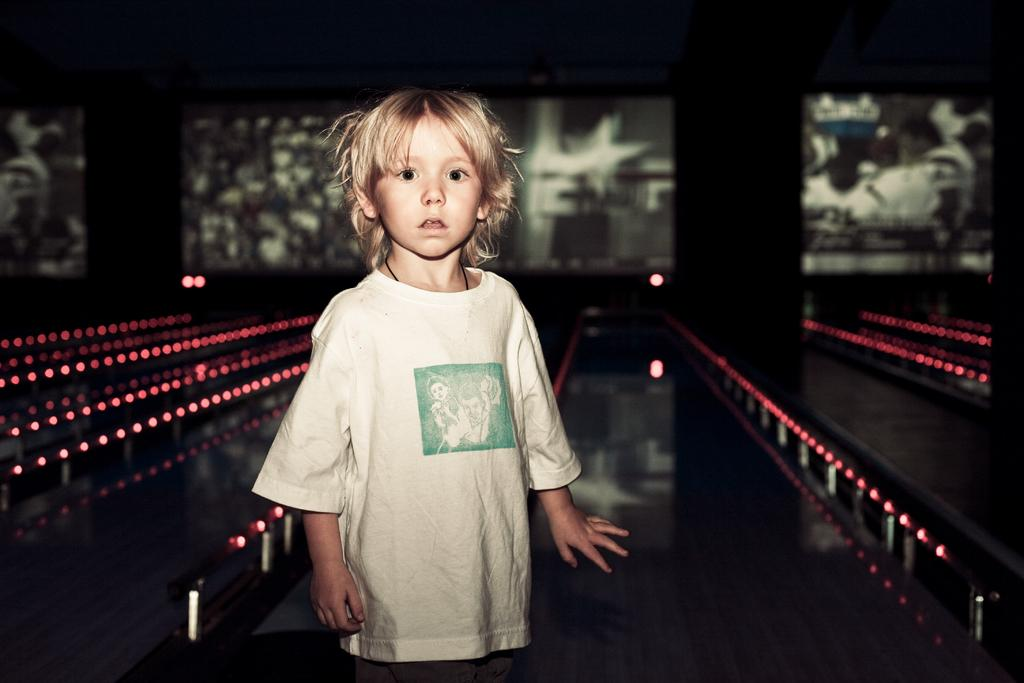What is the main subject of the image? There is a child in the image. What type of surface is visible in the image? There is ground visible in the image. What can be found on the ground in the image? There are objects on the ground. What can be seen providing illumination in the image? There are lights in the image. What is on the wall in the image? There is a wall with posters in the image. What is the title of the book the child is reading in the image? There is no book visible in the image, so it is not possible to determine the title. Is there a crook present in the image? There is no crook present in the image. 